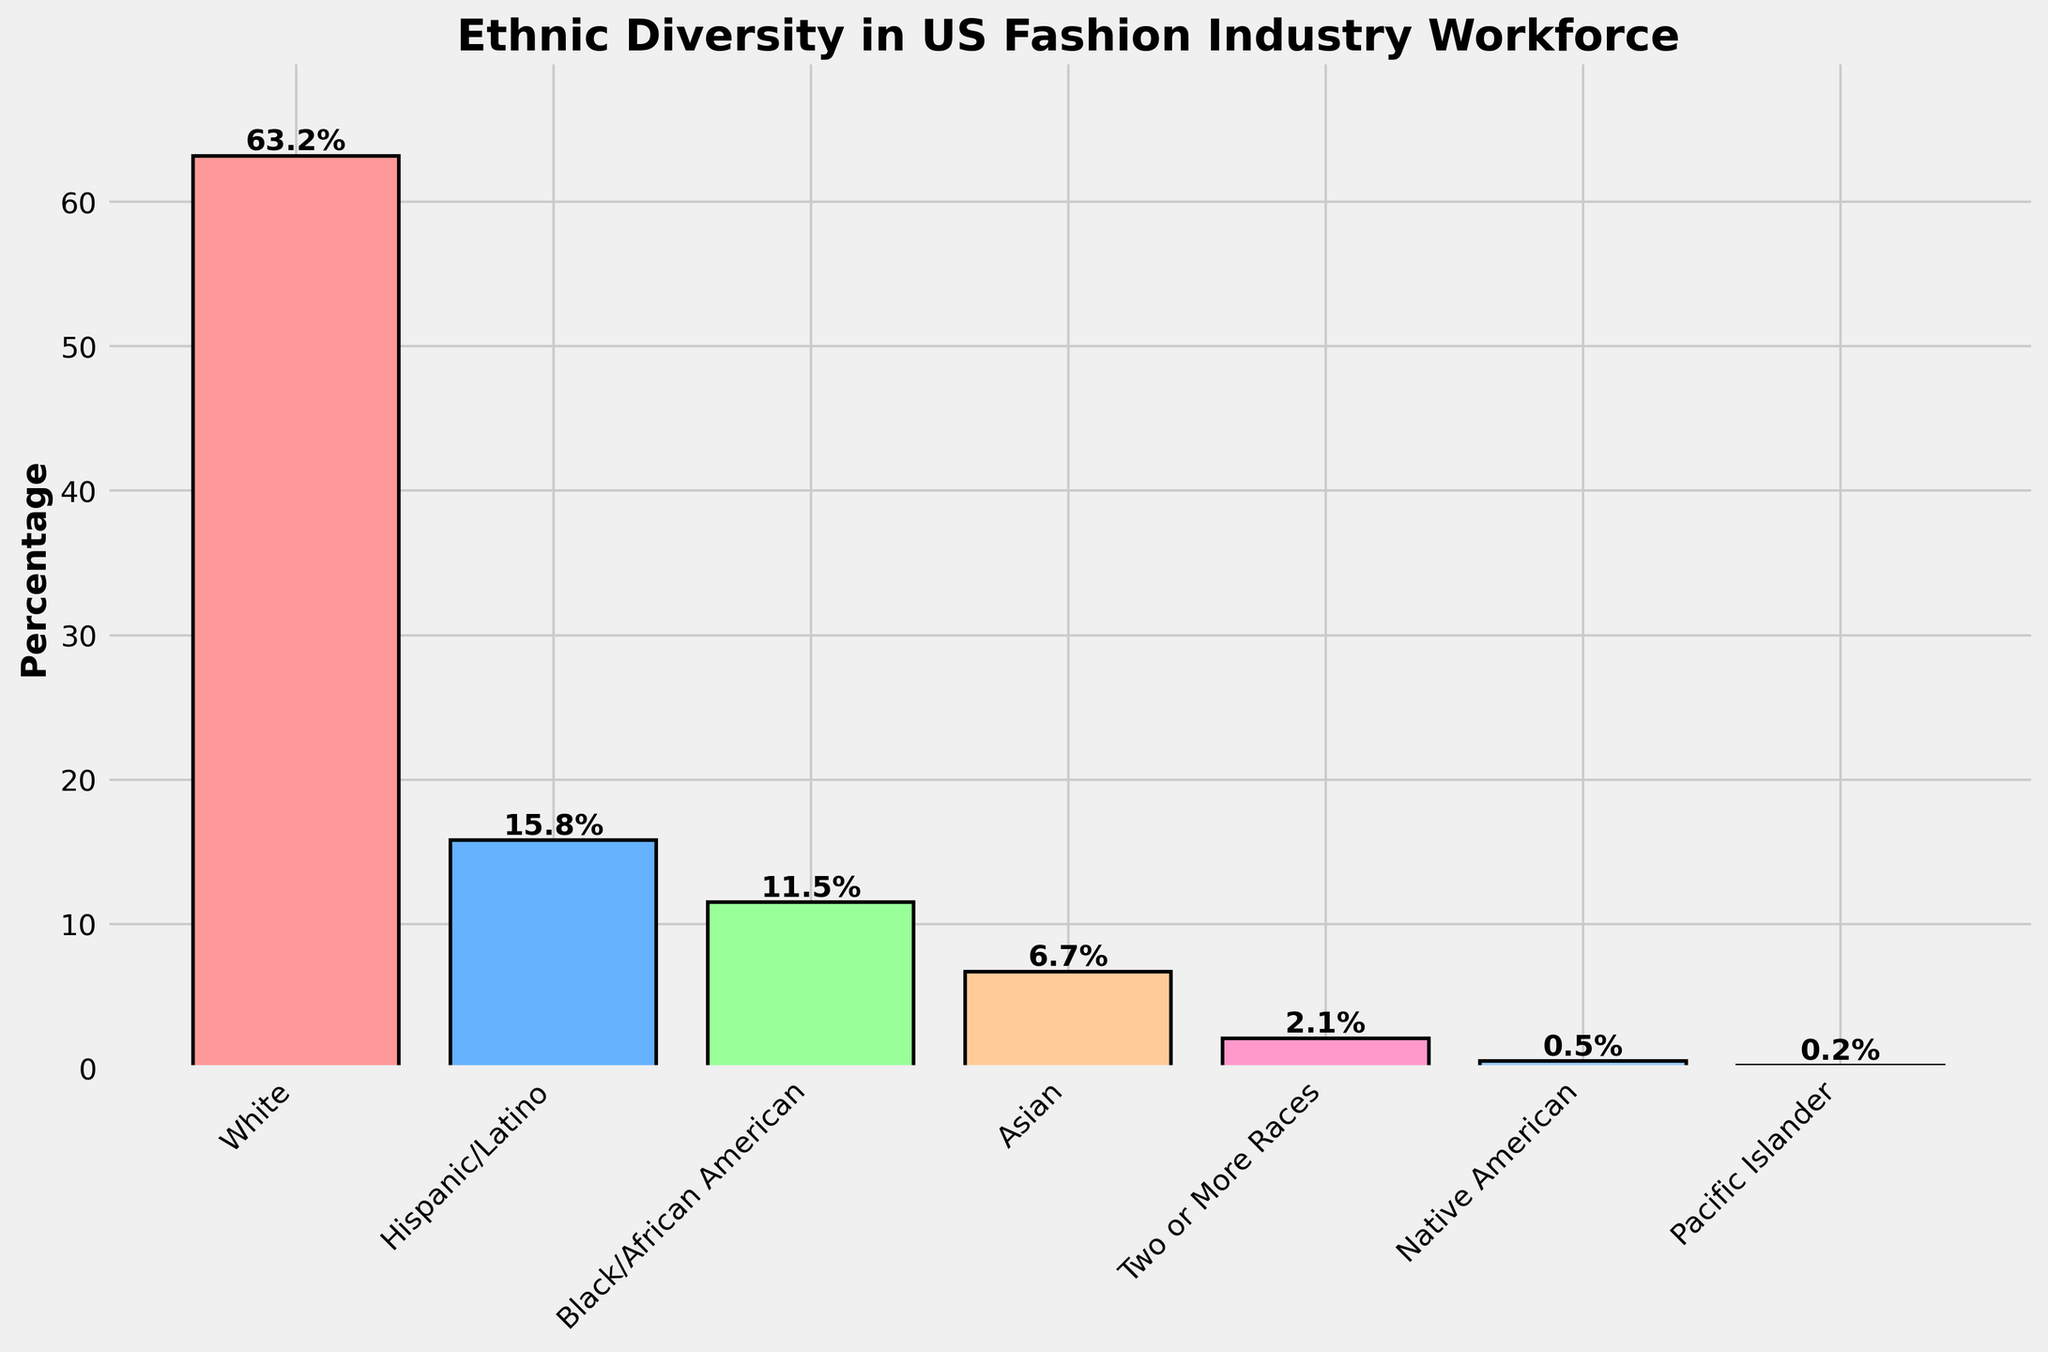Which ethnic group has the highest percentage of representation in the US fashion industry workforce? By looking at the height of the bars, the tallest bar represents the White ethnic group. The value at the top of this bar indicates 63.2%.
Answer: White Which two ethnic groups have a combined percentage of 27.3%? By adding the percentages of Hispanic/Latino (15.8%) and Black/African American (11.5%), we get 15.8% + 11.5% = 27.3%.
Answer: Hispanic/Latino and Black/African American How much higher is the representation of White workers compared to Asian workers? The percentage for White workers is 63.2% and for Asian workers is 6.7%. The difference is 63.2% - 6.7% = 56.5%.
Answer: 56.5% What is the combined percentage of ethnic groups that each have less than or equal to 2.1% representation? Add the percentages of Two or More Races (2.1%), Native American (0.5%), and Pacific Islander (0.2%). So, 2.1% + 0.5% + 0.2% = 2.8%.
Answer: 2.8% What is the total percentage of non-White workers in the US fashion industry workforce? Sum up the percentages of Hispanic/Latino (15.8%), Black/African American (11.5%), Asian (6.7%), Two or More Races (2.1%), Native American (0.5%), and Pacific Islander (0.2%). So, 15.8% + 11.5% + 6.7% + 2.1% + 0.5% + 0.2% = 36.8%.
Answer: 36.8% Which bar is the shortest in the plot and what does it represent? The shortest bar represents the Pacific Islander ethnic group with a percentage of 0.2%.
Answer: Pacific Islander (0.2%) How many ethnic groups have less than 10% representation? By inspecting the bar heights and their respective percentages, Hispanic/Latino (15.8%) and Black/African American (11.5%) exceed 10%. The others: Asian (6.7%), Two or More Races (2.1%), Native American (0.5%), and Pacific Islander (0.2%) are less than 10%. That's 4 groups.
Answer: 4 What is the average percentage of representation for the groups with more than 10% representation? The groups with more than 10% representation are White (63.2%), Hispanic/Latino (15.8%), and Black/African American (11.5%). The average is calculated as (63.2% + 15.8% + 11.5%) ÷ 3. So, (90.5%) ÷ 3 ≈ 30.17%.
Answer: 30.17% 